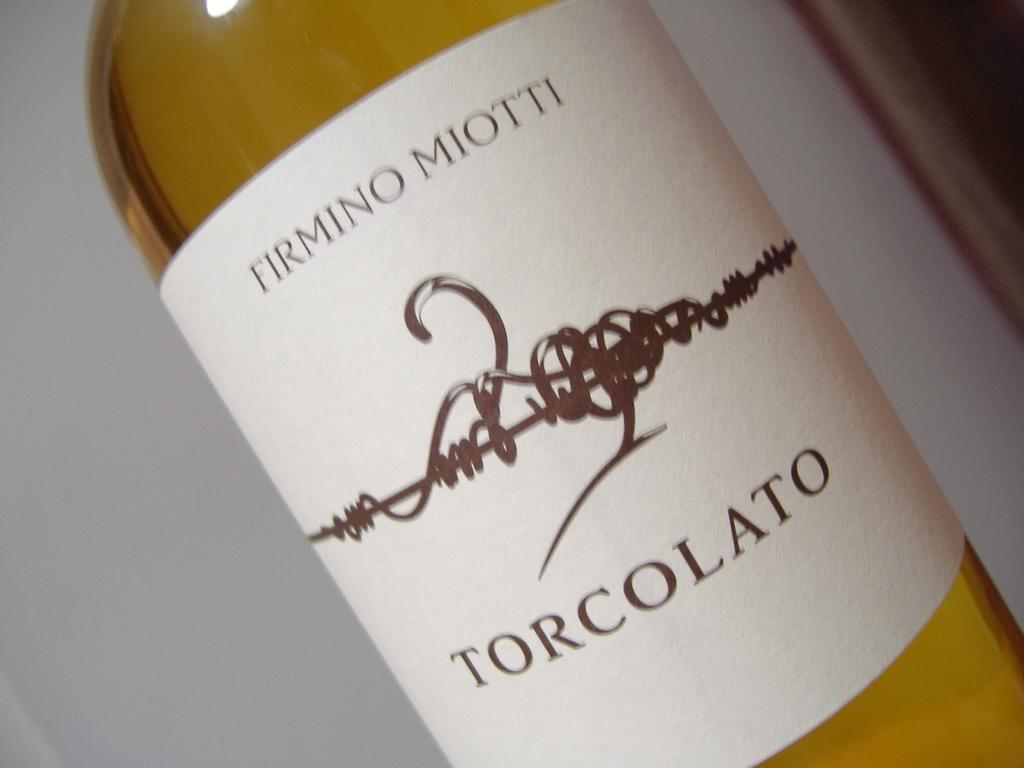<image>
Describe the image concisely. "FIRMINO MIOTTI TORCOLATO" is on a wine label. 